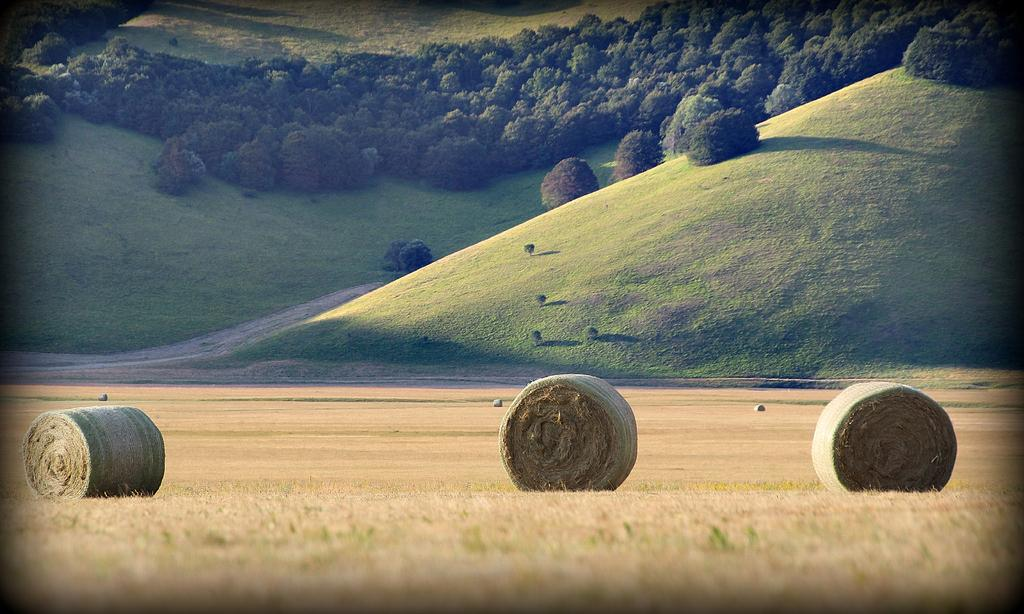What objects are present in the image? There are dried grass rolls in the image. What can be seen in the background of the image? There is grass and plants in green color visible in the background of the image. What type of book is being read by the mice in the image? There are no mice or books present in the image; it only features dried grass rolls and green plants in the background. 